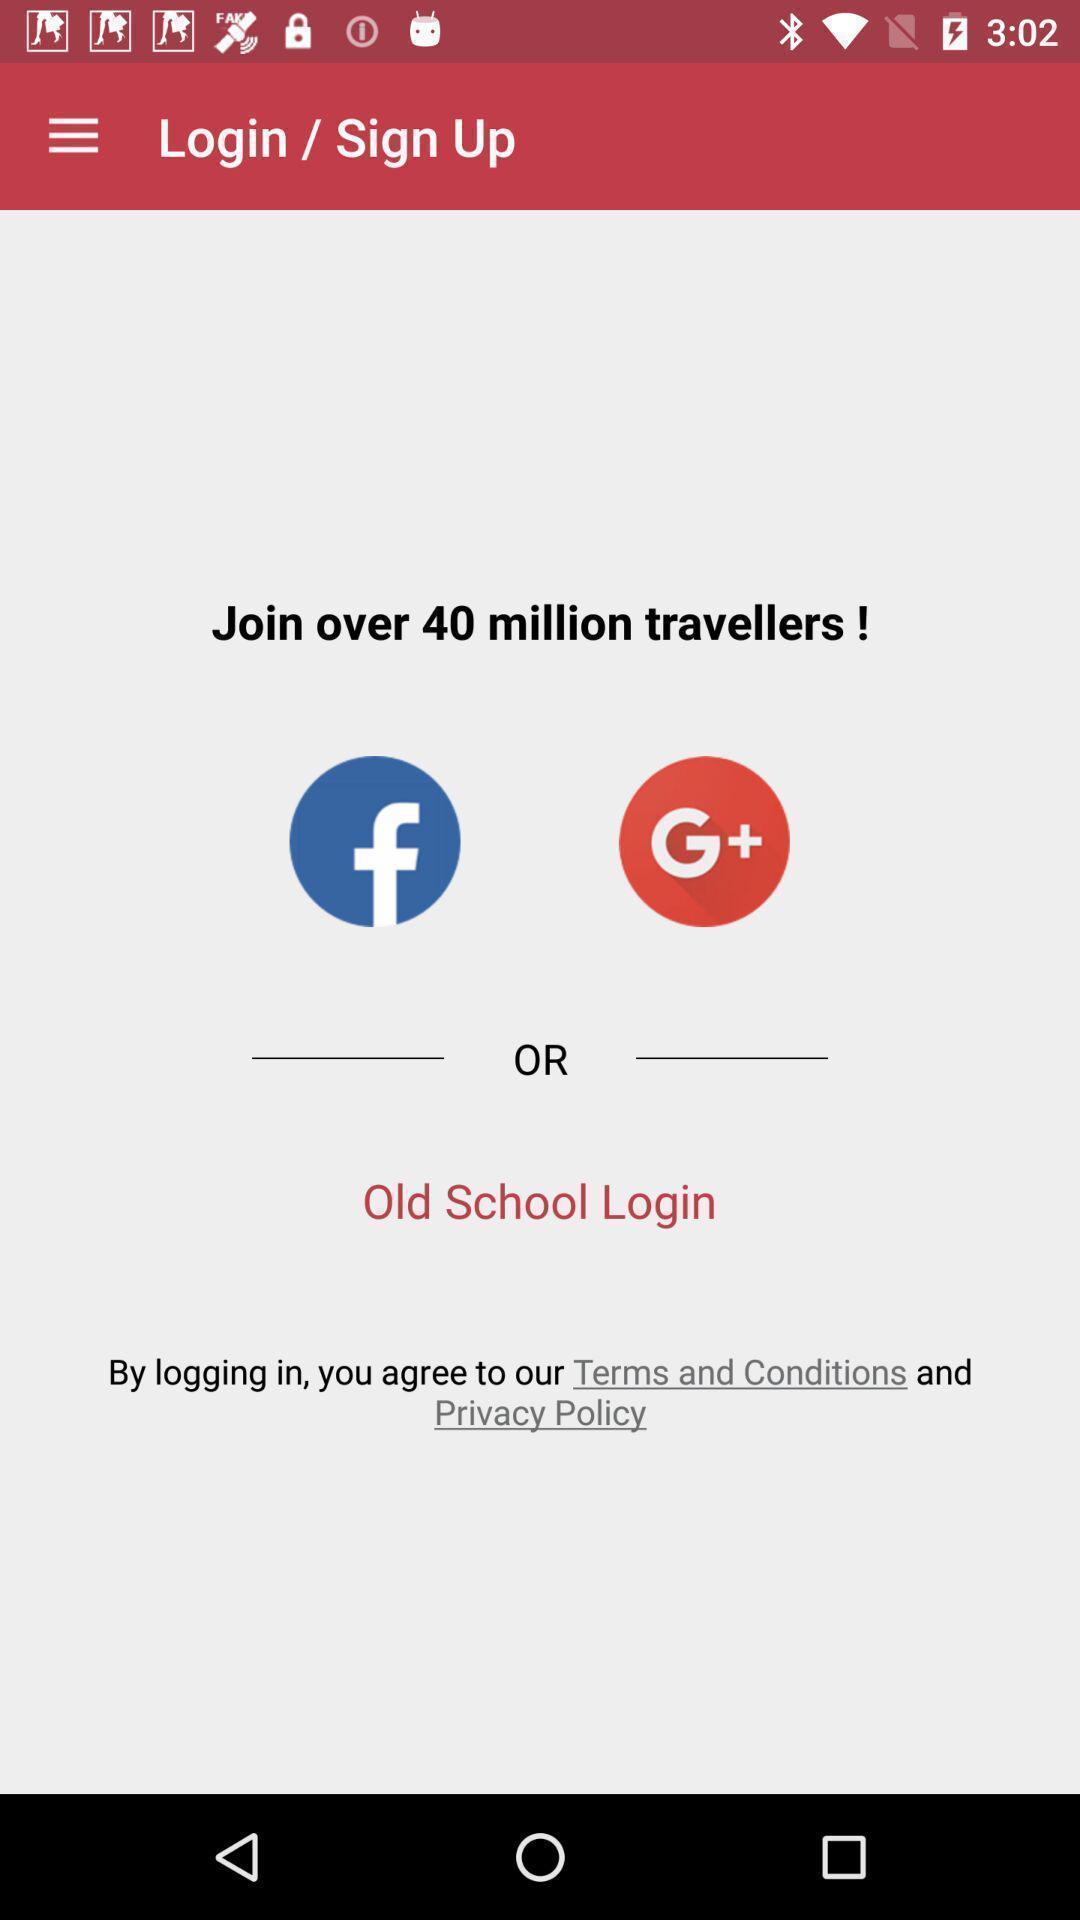Provide a detailed account of this screenshot. Login page with different social apps displayed. 